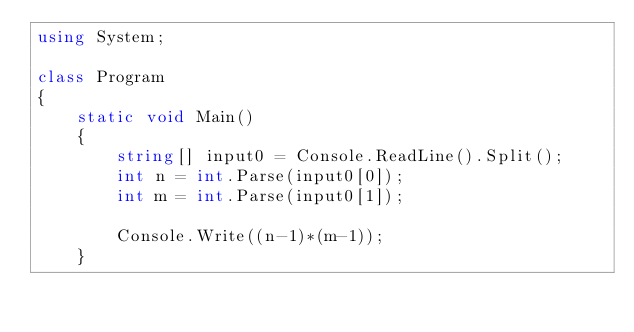<code> <loc_0><loc_0><loc_500><loc_500><_C#_>using System;

class Program
{
    static void Main()
    {
        string[] input0 = Console.ReadLine().Split();
        int n = int.Parse(input0[0]);
        int m = int.Parse(input0[1]);

        Console.Write((n-1)*(m-1));
    }</code> 